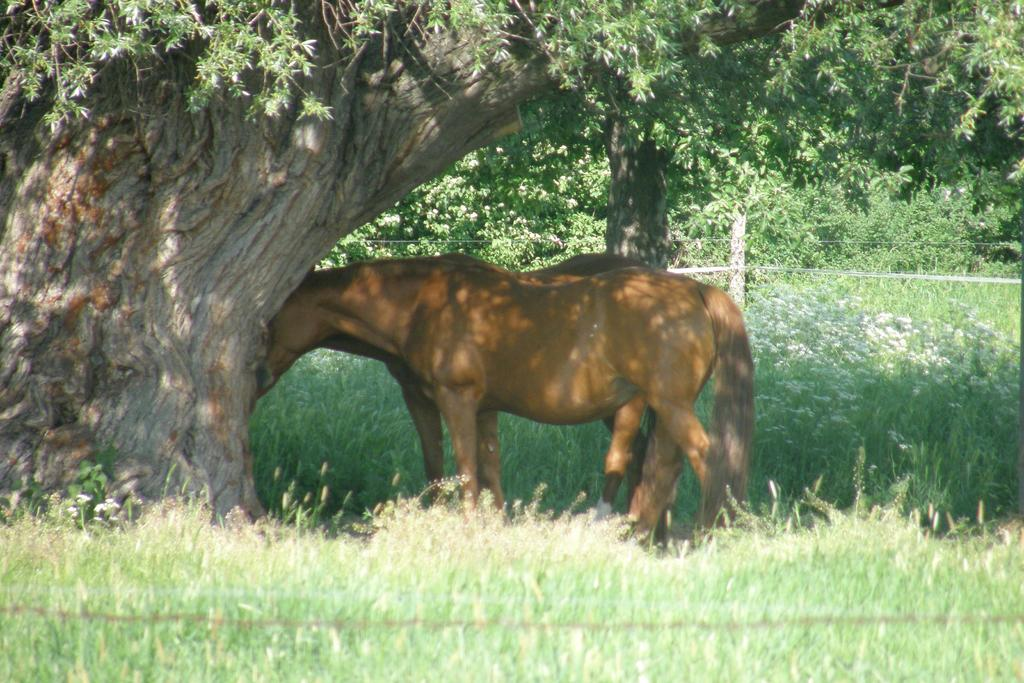What type of natural environment is depicted in the image? The image contains a forest. What are the main features of the forest? There are trees and bushes in the forest. Can you describe any man-made structures in the image? There is a pole visible in the middle of the image. What animals can be seen in the image? Two animals are visible in front of a tree. What type of cloud can be seen in the image? There is no cloud visible in the image; it is set in a forest. How does the anger of the animals affect the forest in the image? There is no indication of anger in the image, and the animals' emotions do not affect the forest. 